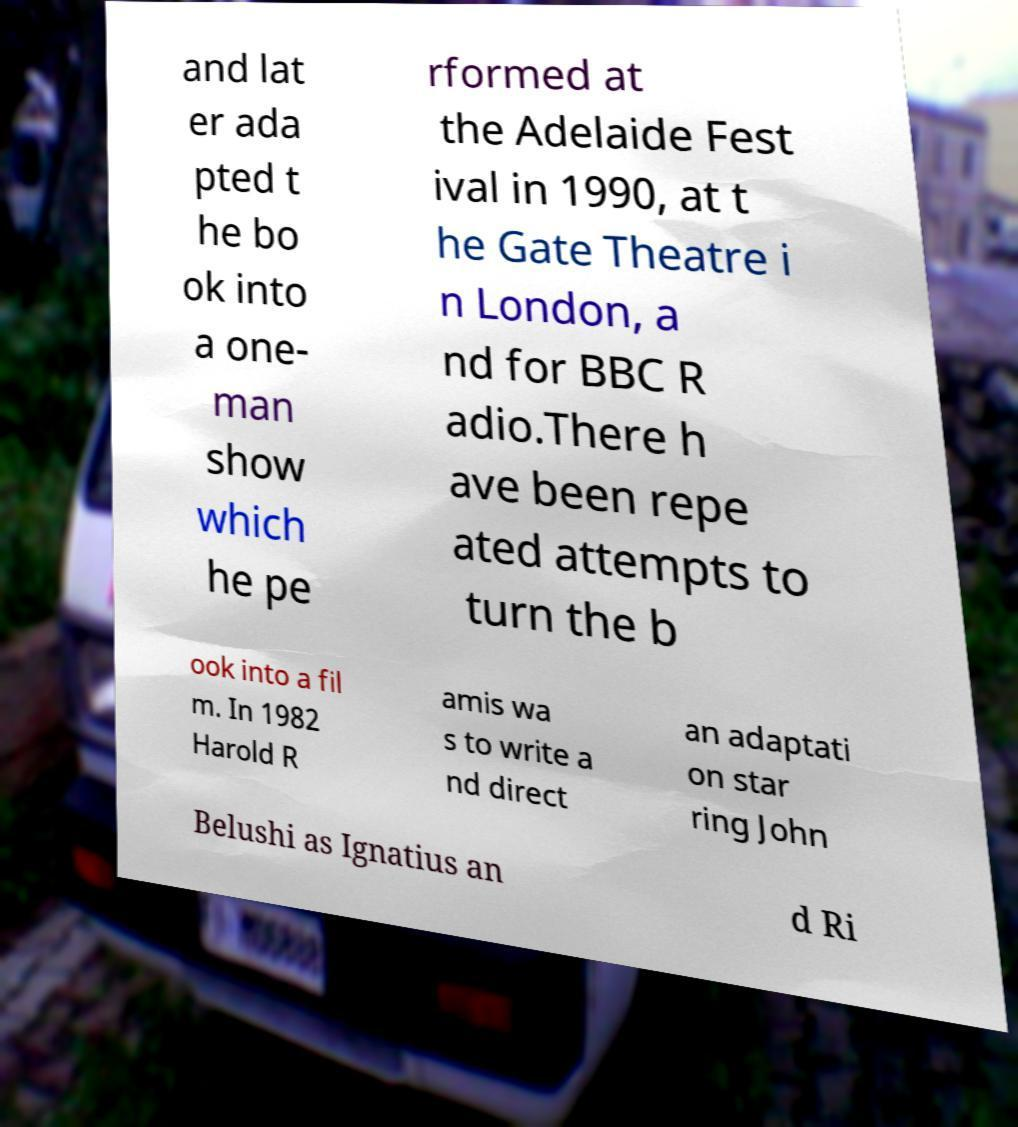There's text embedded in this image that I need extracted. Can you transcribe it verbatim? and lat er ada pted t he bo ok into a one- man show which he pe rformed at the Adelaide Fest ival in 1990, at t he Gate Theatre i n London, a nd for BBC R adio.There h ave been repe ated attempts to turn the b ook into a fil m. In 1982 Harold R amis wa s to write a nd direct an adaptati on star ring John Belushi as Ignatius an d Ri 